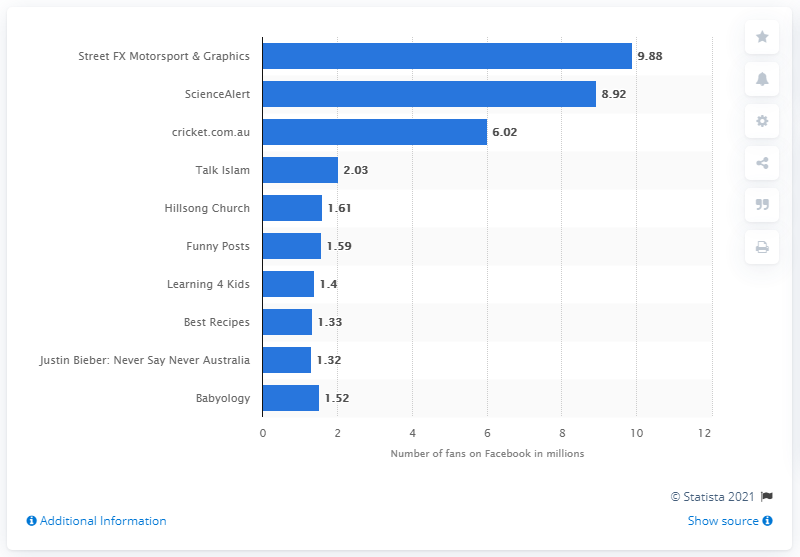Indicate a few pertinent items in this graphic. As of March 2017, Street FX Motorsport and Graphics had 9.88 fans. 